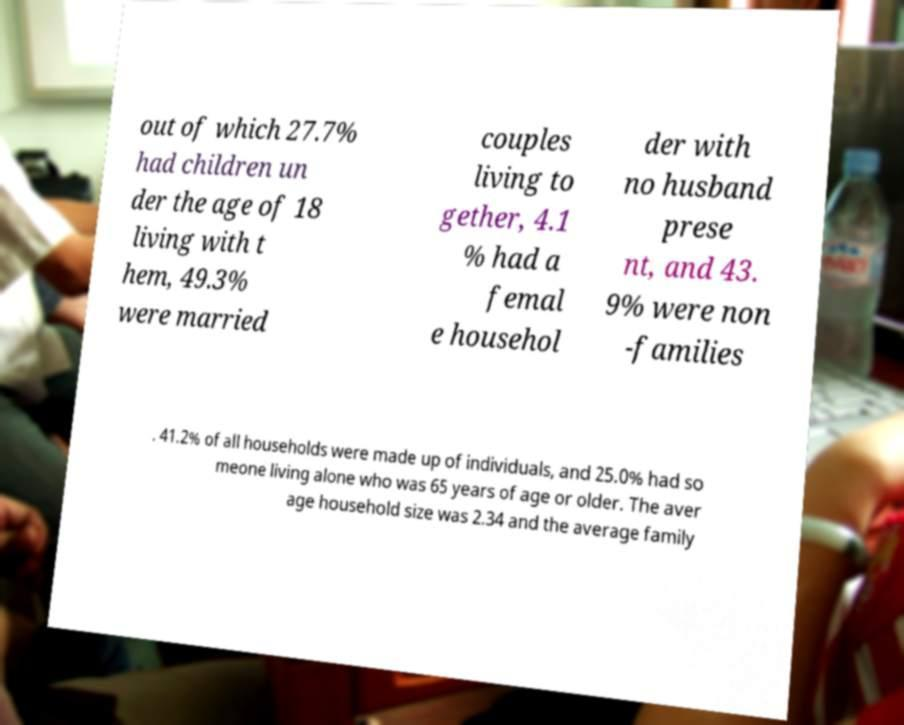There's text embedded in this image that I need extracted. Can you transcribe it verbatim? out of which 27.7% had children un der the age of 18 living with t hem, 49.3% were married couples living to gether, 4.1 % had a femal e househol der with no husband prese nt, and 43. 9% were non -families . 41.2% of all households were made up of individuals, and 25.0% had so meone living alone who was 65 years of age or older. The aver age household size was 2.34 and the average family 